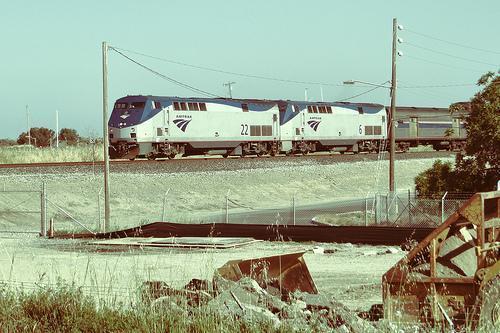How many goats are standing around the train tracks?
Give a very brief answer. 0. 